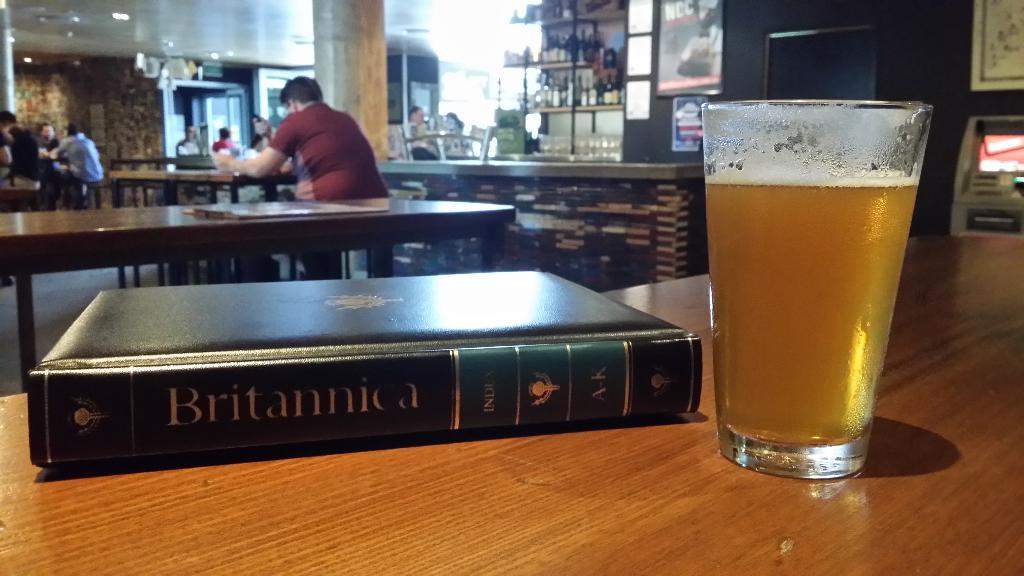<image>
Relay a brief, clear account of the picture shown. Cup of beer next to a book that says "Britannica". 